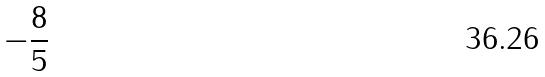<formula> <loc_0><loc_0><loc_500><loc_500>- \frac { 8 } { 5 }</formula> 